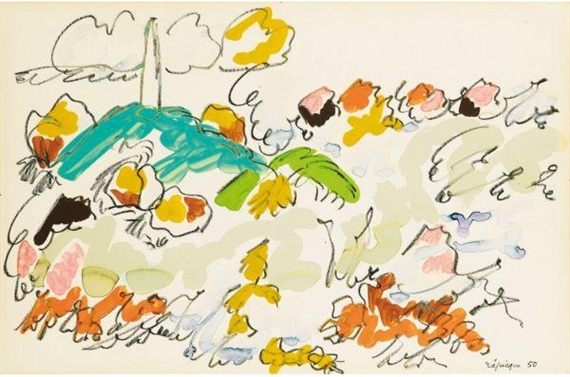Can you create a short story inspired by this artwork? Once upon a time, in a land where colors danced and lines sang, there was a garden unlike any other. This garden was home to a mystical blue bird named Azure and a wise old palm tree named Verdant. Azure loved to explore the garden, flying through the bright flowers and playing with the colorful clouds. One day, Azure discovered a hidden path lined with the most radiant flowers she had ever seen. As she followed it, she met playful spirits of the flowers who invited her to join their eternal dance. Azure twirled and fluttered, creating a symphony of joy that echoed through the garden, bringing smiles to every blossom and leaf. And so, Azure and her friends danced forever, making the garden a place of endless wonder and happiness. 